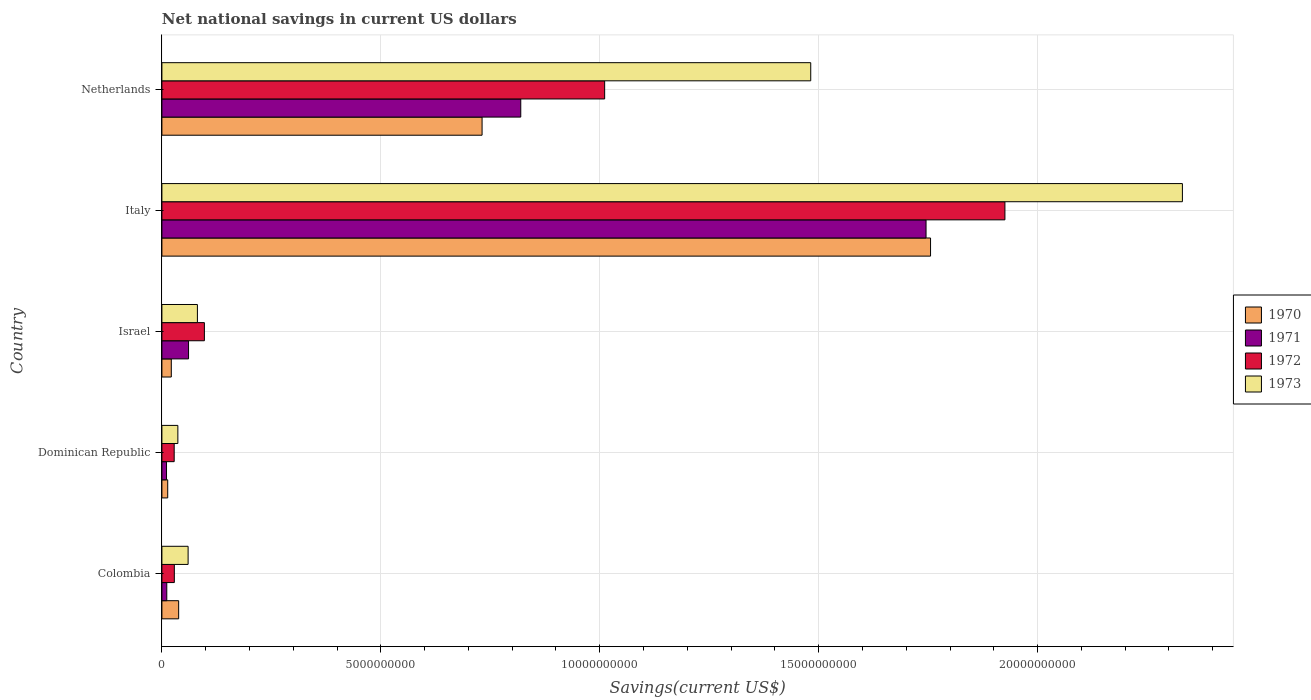Are the number of bars per tick equal to the number of legend labels?
Ensure brevity in your answer.  Yes. How many bars are there on the 2nd tick from the top?
Keep it short and to the point. 4. What is the label of the 3rd group of bars from the top?
Offer a terse response. Israel. What is the net national savings in 1972 in Colombia?
Your response must be concise. 2.84e+08. Across all countries, what is the maximum net national savings in 1973?
Ensure brevity in your answer.  2.33e+1. Across all countries, what is the minimum net national savings in 1970?
Ensure brevity in your answer.  1.33e+08. In which country was the net national savings in 1971 maximum?
Ensure brevity in your answer.  Italy. In which country was the net national savings in 1971 minimum?
Make the answer very short. Dominican Republic. What is the total net national savings in 1972 in the graph?
Your response must be concise. 3.09e+1. What is the difference between the net national savings in 1970 in Colombia and that in Israel?
Your answer should be compact. 1.68e+08. What is the difference between the net national savings in 1972 in Colombia and the net national savings in 1973 in Netherlands?
Offer a very short reply. -1.45e+1. What is the average net national savings in 1972 per country?
Provide a succinct answer. 6.18e+09. What is the difference between the net national savings in 1972 and net national savings in 1971 in Dominican Republic?
Provide a short and direct response. 1.75e+08. In how many countries, is the net national savings in 1973 greater than 11000000000 US$?
Make the answer very short. 2. What is the ratio of the net national savings in 1971 in Dominican Republic to that in Italy?
Keep it short and to the point. 0.01. What is the difference between the highest and the second highest net national savings in 1973?
Make the answer very short. 8.49e+09. What is the difference between the highest and the lowest net national savings in 1973?
Ensure brevity in your answer.  2.29e+1. Is the sum of the net national savings in 1972 in Colombia and Italy greater than the maximum net national savings in 1973 across all countries?
Make the answer very short. No. Is it the case that in every country, the sum of the net national savings in 1971 and net national savings in 1970 is greater than the sum of net national savings in 1972 and net national savings in 1973?
Your answer should be very brief. No. How many bars are there?
Offer a very short reply. 20. How many countries are there in the graph?
Ensure brevity in your answer.  5. What is the difference between two consecutive major ticks on the X-axis?
Give a very brief answer. 5.00e+09. Does the graph contain grids?
Your response must be concise. Yes. How many legend labels are there?
Provide a short and direct response. 4. What is the title of the graph?
Give a very brief answer. Net national savings in current US dollars. What is the label or title of the X-axis?
Provide a short and direct response. Savings(current US$). What is the label or title of the Y-axis?
Offer a terse response. Country. What is the Savings(current US$) of 1970 in Colombia?
Your answer should be very brief. 3.83e+08. What is the Savings(current US$) of 1971 in Colombia?
Provide a short and direct response. 1.11e+08. What is the Savings(current US$) in 1972 in Colombia?
Offer a very short reply. 2.84e+08. What is the Savings(current US$) of 1973 in Colombia?
Your answer should be very brief. 5.98e+08. What is the Savings(current US$) of 1970 in Dominican Republic?
Ensure brevity in your answer.  1.33e+08. What is the Savings(current US$) in 1971 in Dominican Republic?
Provide a short and direct response. 1.05e+08. What is the Savings(current US$) of 1972 in Dominican Republic?
Make the answer very short. 2.80e+08. What is the Savings(current US$) of 1973 in Dominican Republic?
Ensure brevity in your answer.  3.65e+08. What is the Savings(current US$) in 1970 in Israel?
Your answer should be very brief. 2.15e+08. What is the Savings(current US$) of 1971 in Israel?
Give a very brief answer. 6.09e+08. What is the Savings(current US$) of 1972 in Israel?
Give a very brief answer. 9.71e+08. What is the Savings(current US$) in 1973 in Israel?
Offer a terse response. 8.11e+08. What is the Savings(current US$) in 1970 in Italy?
Make the answer very short. 1.76e+1. What is the Savings(current US$) in 1971 in Italy?
Make the answer very short. 1.75e+1. What is the Savings(current US$) of 1972 in Italy?
Give a very brief answer. 1.93e+1. What is the Savings(current US$) in 1973 in Italy?
Keep it short and to the point. 2.33e+1. What is the Savings(current US$) of 1970 in Netherlands?
Give a very brief answer. 7.31e+09. What is the Savings(current US$) of 1971 in Netherlands?
Keep it short and to the point. 8.20e+09. What is the Savings(current US$) in 1972 in Netherlands?
Ensure brevity in your answer.  1.01e+1. What is the Savings(current US$) in 1973 in Netherlands?
Ensure brevity in your answer.  1.48e+1. Across all countries, what is the maximum Savings(current US$) of 1970?
Keep it short and to the point. 1.76e+1. Across all countries, what is the maximum Savings(current US$) in 1971?
Your answer should be very brief. 1.75e+1. Across all countries, what is the maximum Savings(current US$) of 1972?
Ensure brevity in your answer.  1.93e+1. Across all countries, what is the maximum Savings(current US$) of 1973?
Give a very brief answer. 2.33e+1. Across all countries, what is the minimum Savings(current US$) in 1970?
Your response must be concise. 1.33e+08. Across all countries, what is the minimum Savings(current US$) of 1971?
Offer a very short reply. 1.05e+08. Across all countries, what is the minimum Savings(current US$) of 1972?
Provide a succinct answer. 2.80e+08. Across all countries, what is the minimum Savings(current US$) in 1973?
Ensure brevity in your answer.  3.65e+08. What is the total Savings(current US$) in 1970 in the graph?
Your response must be concise. 2.56e+1. What is the total Savings(current US$) of 1971 in the graph?
Offer a terse response. 2.65e+1. What is the total Savings(current US$) in 1972 in the graph?
Your answer should be compact. 3.09e+1. What is the total Savings(current US$) of 1973 in the graph?
Offer a very short reply. 3.99e+1. What is the difference between the Savings(current US$) of 1970 in Colombia and that in Dominican Republic?
Provide a succinct answer. 2.50e+08. What is the difference between the Savings(current US$) in 1971 in Colombia and that in Dominican Republic?
Your response must be concise. 6.03e+06. What is the difference between the Savings(current US$) of 1972 in Colombia and that in Dominican Republic?
Provide a short and direct response. 3.48e+06. What is the difference between the Savings(current US$) in 1973 in Colombia and that in Dominican Republic?
Give a very brief answer. 2.34e+08. What is the difference between the Savings(current US$) of 1970 in Colombia and that in Israel?
Your answer should be compact. 1.68e+08. What is the difference between the Savings(current US$) of 1971 in Colombia and that in Israel?
Provide a short and direct response. -4.97e+08. What is the difference between the Savings(current US$) in 1972 in Colombia and that in Israel?
Make the answer very short. -6.87e+08. What is the difference between the Savings(current US$) of 1973 in Colombia and that in Israel?
Offer a terse response. -2.12e+08. What is the difference between the Savings(current US$) of 1970 in Colombia and that in Italy?
Ensure brevity in your answer.  -1.72e+1. What is the difference between the Savings(current US$) in 1971 in Colombia and that in Italy?
Keep it short and to the point. -1.73e+1. What is the difference between the Savings(current US$) in 1972 in Colombia and that in Italy?
Ensure brevity in your answer.  -1.90e+1. What is the difference between the Savings(current US$) of 1973 in Colombia and that in Italy?
Offer a terse response. -2.27e+1. What is the difference between the Savings(current US$) of 1970 in Colombia and that in Netherlands?
Your response must be concise. -6.93e+09. What is the difference between the Savings(current US$) of 1971 in Colombia and that in Netherlands?
Offer a terse response. -8.08e+09. What is the difference between the Savings(current US$) of 1972 in Colombia and that in Netherlands?
Keep it short and to the point. -9.83e+09. What is the difference between the Savings(current US$) of 1973 in Colombia and that in Netherlands?
Keep it short and to the point. -1.42e+1. What is the difference between the Savings(current US$) in 1970 in Dominican Republic and that in Israel?
Provide a succinct answer. -8.19e+07. What is the difference between the Savings(current US$) of 1971 in Dominican Republic and that in Israel?
Give a very brief answer. -5.03e+08. What is the difference between the Savings(current US$) in 1972 in Dominican Republic and that in Israel?
Your response must be concise. -6.90e+08. What is the difference between the Savings(current US$) in 1973 in Dominican Republic and that in Israel?
Make the answer very short. -4.46e+08. What is the difference between the Savings(current US$) of 1970 in Dominican Republic and that in Italy?
Your answer should be compact. -1.74e+1. What is the difference between the Savings(current US$) of 1971 in Dominican Republic and that in Italy?
Provide a succinct answer. -1.73e+1. What is the difference between the Savings(current US$) of 1972 in Dominican Republic and that in Italy?
Ensure brevity in your answer.  -1.90e+1. What is the difference between the Savings(current US$) of 1973 in Dominican Republic and that in Italy?
Make the answer very short. -2.29e+1. What is the difference between the Savings(current US$) of 1970 in Dominican Republic and that in Netherlands?
Make the answer very short. -7.18e+09. What is the difference between the Savings(current US$) of 1971 in Dominican Republic and that in Netherlands?
Offer a terse response. -8.09e+09. What is the difference between the Savings(current US$) of 1972 in Dominican Republic and that in Netherlands?
Keep it short and to the point. -9.83e+09. What is the difference between the Savings(current US$) in 1973 in Dominican Republic and that in Netherlands?
Keep it short and to the point. -1.45e+1. What is the difference between the Savings(current US$) of 1970 in Israel and that in Italy?
Your answer should be compact. -1.73e+1. What is the difference between the Savings(current US$) of 1971 in Israel and that in Italy?
Your response must be concise. -1.68e+1. What is the difference between the Savings(current US$) of 1972 in Israel and that in Italy?
Offer a terse response. -1.83e+1. What is the difference between the Savings(current US$) of 1973 in Israel and that in Italy?
Provide a short and direct response. -2.25e+1. What is the difference between the Savings(current US$) in 1970 in Israel and that in Netherlands?
Your answer should be very brief. -7.10e+09. What is the difference between the Savings(current US$) of 1971 in Israel and that in Netherlands?
Give a very brief answer. -7.59e+09. What is the difference between the Savings(current US$) of 1972 in Israel and that in Netherlands?
Give a very brief answer. -9.14e+09. What is the difference between the Savings(current US$) of 1973 in Israel and that in Netherlands?
Make the answer very short. -1.40e+1. What is the difference between the Savings(current US$) of 1970 in Italy and that in Netherlands?
Offer a very short reply. 1.02e+1. What is the difference between the Savings(current US$) in 1971 in Italy and that in Netherlands?
Provide a short and direct response. 9.26e+09. What is the difference between the Savings(current US$) in 1972 in Italy and that in Netherlands?
Ensure brevity in your answer.  9.14e+09. What is the difference between the Savings(current US$) of 1973 in Italy and that in Netherlands?
Give a very brief answer. 8.49e+09. What is the difference between the Savings(current US$) in 1970 in Colombia and the Savings(current US$) in 1971 in Dominican Republic?
Your response must be concise. 2.77e+08. What is the difference between the Savings(current US$) of 1970 in Colombia and the Savings(current US$) of 1972 in Dominican Republic?
Ensure brevity in your answer.  1.02e+08. What is the difference between the Savings(current US$) of 1970 in Colombia and the Savings(current US$) of 1973 in Dominican Republic?
Give a very brief answer. 1.82e+07. What is the difference between the Savings(current US$) of 1971 in Colombia and the Savings(current US$) of 1972 in Dominican Republic?
Give a very brief answer. -1.69e+08. What is the difference between the Savings(current US$) of 1971 in Colombia and the Savings(current US$) of 1973 in Dominican Republic?
Your response must be concise. -2.53e+08. What is the difference between the Savings(current US$) in 1972 in Colombia and the Savings(current US$) in 1973 in Dominican Republic?
Ensure brevity in your answer.  -8.05e+07. What is the difference between the Savings(current US$) in 1970 in Colombia and the Savings(current US$) in 1971 in Israel?
Ensure brevity in your answer.  -2.26e+08. What is the difference between the Savings(current US$) in 1970 in Colombia and the Savings(current US$) in 1972 in Israel?
Keep it short and to the point. -5.88e+08. What is the difference between the Savings(current US$) of 1970 in Colombia and the Savings(current US$) of 1973 in Israel?
Your answer should be compact. -4.28e+08. What is the difference between the Savings(current US$) of 1971 in Colombia and the Savings(current US$) of 1972 in Israel?
Your answer should be very brief. -8.59e+08. What is the difference between the Savings(current US$) of 1971 in Colombia and the Savings(current US$) of 1973 in Israel?
Offer a terse response. -6.99e+08. What is the difference between the Savings(current US$) of 1972 in Colombia and the Savings(current US$) of 1973 in Israel?
Your answer should be very brief. -5.27e+08. What is the difference between the Savings(current US$) of 1970 in Colombia and the Savings(current US$) of 1971 in Italy?
Your response must be concise. -1.71e+1. What is the difference between the Savings(current US$) of 1970 in Colombia and the Savings(current US$) of 1972 in Italy?
Provide a succinct answer. -1.89e+1. What is the difference between the Savings(current US$) of 1970 in Colombia and the Savings(current US$) of 1973 in Italy?
Offer a very short reply. -2.29e+1. What is the difference between the Savings(current US$) of 1971 in Colombia and the Savings(current US$) of 1972 in Italy?
Ensure brevity in your answer.  -1.91e+1. What is the difference between the Savings(current US$) in 1971 in Colombia and the Savings(current US$) in 1973 in Italy?
Provide a succinct answer. -2.32e+1. What is the difference between the Savings(current US$) in 1972 in Colombia and the Savings(current US$) in 1973 in Italy?
Make the answer very short. -2.30e+1. What is the difference between the Savings(current US$) of 1970 in Colombia and the Savings(current US$) of 1971 in Netherlands?
Keep it short and to the point. -7.81e+09. What is the difference between the Savings(current US$) in 1970 in Colombia and the Savings(current US$) in 1972 in Netherlands?
Your response must be concise. -9.73e+09. What is the difference between the Savings(current US$) of 1970 in Colombia and the Savings(current US$) of 1973 in Netherlands?
Your answer should be compact. -1.44e+1. What is the difference between the Savings(current US$) of 1971 in Colombia and the Savings(current US$) of 1972 in Netherlands?
Offer a very short reply. -1.00e+1. What is the difference between the Savings(current US$) of 1971 in Colombia and the Savings(current US$) of 1973 in Netherlands?
Your answer should be compact. -1.47e+1. What is the difference between the Savings(current US$) in 1972 in Colombia and the Savings(current US$) in 1973 in Netherlands?
Your answer should be very brief. -1.45e+1. What is the difference between the Savings(current US$) of 1970 in Dominican Republic and the Savings(current US$) of 1971 in Israel?
Offer a terse response. -4.76e+08. What is the difference between the Savings(current US$) of 1970 in Dominican Republic and the Savings(current US$) of 1972 in Israel?
Your answer should be very brief. -8.38e+08. What is the difference between the Savings(current US$) in 1970 in Dominican Republic and the Savings(current US$) in 1973 in Israel?
Ensure brevity in your answer.  -6.78e+08. What is the difference between the Savings(current US$) of 1971 in Dominican Republic and the Savings(current US$) of 1972 in Israel?
Give a very brief answer. -8.65e+08. What is the difference between the Savings(current US$) in 1971 in Dominican Republic and the Savings(current US$) in 1973 in Israel?
Offer a very short reply. -7.05e+08. What is the difference between the Savings(current US$) in 1972 in Dominican Republic and the Savings(current US$) in 1973 in Israel?
Provide a succinct answer. -5.30e+08. What is the difference between the Savings(current US$) of 1970 in Dominican Republic and the Savings(current US$) of 1971 in Italy?
Offer a very short reply. -1.73e+1. What is the difference between the Savings(current US$) in 1970 in Dominican Republic and the Savings(current US$) in 1972 in Italy?
Your answer should be compact. -1.91e+1. What is the difference between the Savings(current US$) in 1970 in Dominican Republic and the Savings(current US$) in 1973 in Italy?
Provide a short and direct response. -2.32e+1. What is the difference between the Savings(current US$) of 1971 in Dominican Republic and the Savings(current US$) of 1972 in Italy?
Give a very brief answer. -1.91e+1. What is the difference between the Savings(current US$) of 1971 in Dominican Republic and the Savings(current US$) of 1973 in Italy?
Make the answer very short. -2.32e+1. What is the difference between the Savings(current US$) in 1972 in Dominican Republic and the Savings(current US$) in 1973 in Italy?
Keep it short and to the point. -2.30e+1. What is the difference between the Savings(current US$) in 1970 in Dominican Republic and the Savings(current US$) in 1971 in Netherlands?
Your answer should be very brief. -8.06e+09. What is the difference between the Savings(current US$) in 1970 in Dominican Republic and the Savings(current US$) in 1972 in Netherlands?
Give a very brief answer. -9.98e+09. What is the difference between the Savings(current US$) in 1970 in Dominican Republic and the Savings(current US$) in 1973 in Netherlands?
Your answer should be compact. -1.47e+1. What is the difference between the Savings(current US$) of 1971 in Dominican Republic and the Savings(current US$) of 1972 in Netherlands?
Make the answer very short. -1.00e+1. What is the difference between the Savings(current US$) of 1971 in Dominican Republic and the Savings(current US$) of 1973 in Netherlands?
Offer a terse response. -1.47e+1. What is the difference between the Savings(current US$) in 1972 in Dominican Republic and the Savings(current US$) in 1973 in Netherlands?
Your answer should be very brief. -1.45e+1. What is the difference between the Savings(current US$) of 1970 in Israel and the Savings(current US$) of 1971 in Italy?
Make the answer very short. -1.72e+1. What is the difference between the Savings(current US$) of 1970 in Israel and the Savings(current US$) of 1972 in Italy?
Give a very brief answer. -1.90e+1. What is the difference between the Savings(current US$) of 1970 in Israel and the Savings(current US$) of 1973 in Italy?
Your answer should be very brief. -2.31e+1. What is the difference between the Savings(current US$) in 1971 in Israel and the Savings(current US$) in 1972 in Italy?
Your response must be concise. -1.86e+1. What is the difference between the Savings(current US$) in 1971 in Israel and the Savings(current US$) in 1973 in Italy?
Ensure brevity in your answer.  -2.27e+1. What is the difference between the Savings(current US$) of 1972 in Israel and the Savings(current US$) of 1973 in Italy?
Offer a very short reply. -2.23e+1. What is the difference between the Savings(current US$) in 1970 in Israel and the Savings(current US$) in 1971 in Netherlands?
Offer a terse response. -7.98e+09. What is the difference between the Savings(current US$) in 1970 in Israel and the Savings(current US$) in 1972 in Netherlands?
Offer a very short reply. -9.90e+09. What is the difference between the Savings(current US$) of 1970 in Israel and the Savings(current US$) of 1973 in Netherlands?
Your answer should be very brief. -1.46e+1. What is the difference between the Savings(current US$) of 1971 in Israel and the Savings(current US$) of 1972 in Netherlands?
Your answer should be very brief. -9.50e+09. What is the difference between the Savings(current US$) in 1971 in Israel and the Savings(current US$) in 1973 in Netherlands?
Give a very brief answer. -1.42e+1. What is the difference between the Savings(current US$) in 1972 in Israel and the Savings(current US$) in 1973 in Netherlands?
Provide a short and direct response. -1.38e+1. What is the difference between the Savings(current US$) in 1970 in Italy and the Savings(current US$) in 1971 in Netherlands?
Provide a succinct answer. 9.36e+09. What is the difference between the Savings(current US$) in 1970 in Italy and the Savings(current US$) in 1972 in Netherlands?
Your answer should be very brief. 7.44e+09. What is the difference between the Savings(current US$) in 1970 in Italy and the Savings(current US$) in 1973 in Netherlands?
Your response must be concise. 2.74e+09. What is the difference between the Savings(current US$) in 1971 in Italy and the Savings(current US$) in 1972 in Netherlands?
Make the answer very short. 7.34e+09. What is the difference between the Savings(current US$) in 1971 in Italy and the Savings(current US$) in 1973 in Netherlands?
Give a very brief answer. 2.63e+09. What is the difference between the Savings(current US$) of 1972 in Italy and the Savings(current US$) of 1973 in Netherlands?
Provide a short and direct response. 4.44e+09. What is the average Savings(current US$) in 1970 per country?
Provide a succinct answer. 5.12e+09. What is the average Savings(current US$) in 1971 per country?
Your answer should be compact. 5.29e+09. What is the average Savings(current US$) in 1972 per country?
Keep it short and to the point. 6.18e+09. What is the average Savings(current US$) of 1973 per country?
Make the answer very short. 7.98e+09. What is the difference between the Savings(current US$) in 1970 and Savings(current US$) in 1971 in Colombia?
Keep it short and to the point. 2.71e+08. What is the difference between the Savings(current US$) of 1970 and Savings(current US$) of 1972 in Colombia?
Your answer should be compact. 9.87e+07. What is the difference between the Savings(current US$) of 1970 and Savings(current US$) of 1973 in Colombia?
Provide a succinct answer. -2.16e+08. What is the difference between the Savings(current US$) in 1971 and Savings(current US$) in 1972 in Colombia?
Offer a very short reply. -1.73e+08. What is the difference between the Savings(current US$) in 1971 and Savings(current US$) in 1973 in Colombia?
Make the answer very short. -4.87e+08. What is the difference between the Savings(current US$) of 1972 and Savings(current US$) of 1973 in Colombia?
Offer a terse response. -3.14e+08. What is the difference between the Savings(current US$) in 1970 and Savings(current US$) in 1971 in Dominican Republic?
Make the answer very short. 2.74e+07. What is the difference between the Savings(current US$) of 1970 and Savings(current US$) of 1972 in Dominican Republic?
Ensure brevity in your answer.  -1.48e+08. What is the difference between the Savings(current US$) in 1970 and Savings(current US$) in 1973 in Dominican Republic?
Your response must be concise. -2.32e+08. What is the difference between the Savings(current US$) of 1971 and Savings(current US$) of 1972 in Dominican Republic?
Your response must be concise. -1.75e+08. What is the difference between the Savings(current US$) in 1971 and Savings(current US$) in 1973 in Dominican Republic?
Your answer should be compact. -2.59e+08. What is the difference between the Savings(current US$) in 1972 and Savings(current US$) in 1973 in Dominican Republic?
Offer a terse response. -8.40e+07. What is the difference between the Savings(current US$) in 1970 and Savings(current US$) in 1971 in Israel?
Provide a succinct answer. -3.94e+08. What is the difference between the Savings(current US$) in 1970 and Savings(current US$) in 1972 in Israel?
Keep it short and to the point. -7.56e+08. What is the difference between the Savings(current US$) in 1970 and Savings(current US$) in 1973 in Israel?
Your answer should be very brief. -5.96e+08. What is the difference between the Savings(current US$) in 1971 and Savings(current US$) in 1972 in Israel?
Provide a succinct answer. -3.62e+08. What is the difference between the Savings(current US$) in 1971 and Savings(current US$) in 1973 in Israel?
Your answer should be compact. -2.02e+08. What is the difference between the Savings(current US$) in 1972 and Savings(current US$) in 1973 in Israel?
Keep it short and to the point. 1.60e+08. What is the difference between the Savings(current US$) in 1970 and Savings(current US$) in 1971 in Italy?
Your answer should be very brief. 1.03e+08. What is the difference between the Savings(current US$) in 1970 and Savings(current US$) in 1972 in Italy?
Your answer should be very brief. -1.70e+09. What is the difference between the Savings(current US$) of 1970 and Savings(current US$) of 1973 in Italy?
Offer a terse response. -5.75e+09. What is the difference between the Savings(current US$) in 1971 and Savings(current US$) in 1972 in Italy?
Ensure brevity in your answer.  -1.80e+09. What is the difference between the Savings(current US$) of 1971 and Savings(current US$) of 1973 in Italy?
Your answer should be compact. -5.86e+09. What is the difference between the Savings(current US$) in 1972 and Savings(current US$) in 1973 in Italy?
Offer a terse response. -4.05e+09. What is the difference between the Savings(current US$) in 1970 and Savings(current US$) in 1971 in Netherlands?
Offer a terse response. -8.83e+08. What is the difference between the Savings(current US$) in 1970 and Savings(current US$) in 1972 in Netherlands?
Offer a terse response. -2.80e+09. What is the difference between the Savings(current US$) of 1970 and Savings(current US$) of 1973 in Netherlands?
Offer a terse response. -7.51e+09. What is the difference between the Savings(current US$) in 1971 and Savings(current US$) in 1972 in Netherlands?
Your answer should be very brief. -1.92e+09. What is the difference between the Savings(current US$) of 1971 and Savings(current US$) of 1973 in Netherlands?
Ensure brevity in your answer.  -6.62e+09. What is the difference between the Savings(current US$) in 1972 and Savings(current US$) in 1973 in Netherlands?
Ensure brevity in your answer.  -4.71e+09. What is the ratio of the Savings(current US$) of 1970 in Colombia to that in Dominican Republic?
Your answer should be compact. 2.88. What is the ratio of the Savings(current US$) of 1971 in Colombia to that in Dominican Republic?
Your response must be concise. 1.06. What is the ratio of the Savings(current US$) in 1972 in Colombia to that in Dominican Republic?
Provide a succinct answer. 1.01. What is the ratio of the Savings(current US$) in 1973 in Colombia to that in Dominican Republic?
Ensure brevity in your answer.  1.64. What is the ratio of the Savings(current US$) of 1970 in Colombia to that in Israel?
Your answer should be compact. 1.78. What is the ratio of the Savings(current US$) in 1971 in Colombia to that in Israel?
Ensure brevity in your answer.  0.18. What is the ratio of the Savings(current US$) in 1972 in Colombia to that in Israel?
Offer a terse response. 0.29. What is the ratio of the Savings(current US$) of 1973 in Colombia to that in Israel?
Keep it short and to the point. 0.74. What is the ratio of the Savings(current US$) of 1970 in Colombia to that in Italy?
Your answer should be very brief. 0.02. What is the ratio of the Savings(current US$) of 1971 in Colombia to that in Italy?
Your response must be concise. 0.01. What is the ratio of the Savings(current US$) of 1972 in Colombia to that in Italy?
Provide a short and direct response. 0.01. What is the ratio of the Savings(current US$) of 1973 in Colombia to that in Italy?
Give a very brief answer. 0.03. What is the ratio of the Savings(current US$) in 1970 in Colombia to that in Netherlands?
Your response must be concise. 0.05. What is the ratio of the Savings(current US$) of 1971 in Colombia to that in Netherlands?
Give a very brief answer. 0.01. What is the ratio of the Savings(current US$) in 1972 in Colombia to that in Netherlands?
Provide a succinct answer. 0.03. What is the ratio of the Savings(current US$) in 1973 in Colombia to that in Netherlands?
Provide a succinct answer. 0.04. What is the ratio of the Savings(current US$) in 1970 in Dominican Republic to that in Israel?
Give a very brief answer. 0.62. What is the ratio of the Savings(current US$) in 1971 in Dominican Republic to that in Israel?
Make the answer very short. 0.17. What is the ratio of the Savings(current US$) of 1972 in Dominican Republic to that in Israel?
Offer a terse response. 0.29. What is the ratio of the Savings(current US$) in 1973 in Dominican Republic to that in Israel?
Make the answer very short. 0.45. What is the ratio of the Savings(current US$) of 1970 in Dominican Republic to that in Italy?
Provide a succinct answer. 0.01. What is the ratio of the Savings(current US$) in 1971 in Dominican Republic to that in Italy?
Give a very brief answer. 0.01. What is the ratio of the Savings(current US$) in 1972 in Dominican Republic to that in Italy?
Your response must be concise. 0.01. What is the ratio of the Savings(current US$) of 1973 in Dominican Republic to that in Italy?
Your answer should be compact. 0.02. What is the ratio of the Savings(current US$) in 1970 in Dominican Republic to that in Netherlands?
Offer a very short reply. 0.02. What is the ratio of the Savings(current US$) in 1971 in Dominican Republic to that in Netherlands?
Your answer should be very brief. 0.01. What is the ratio of the Savings(current US$) of 1972 in Dominican Republic to that in Netherlands?
Keep it short and to the point. 0.03. What is the ratio of the Savings(current US$) of 1973 in Dominican Republic to that in Netherlands?
Your answer should be very brief. 0.02. What is the ratio of the Savings(current US$) of 1970 in Israel to that in Italy?
Give a very brief answer. 0.01. What is the ratio of the Savings(current US$) of 1971 in Israel to that in Italy?
Make the answer very short. 0.03. What is the ratio of the Savings(current US$) of 1972 in Israel to that in Italy?
Ensure brevity in your answer.  0.05. What is the ratio of the Savings(current US$) of 1973 in Israel to that in Italy?
Offer a very short reply. 0.03. What is the ratio of the Savings(current US$) of 1970 in Israel to that in Netherlands?
Keep it short and to the point. 0.03. What is the ratio of the Savings(current US$) of 1971 in Israel to that in Netherlands?
Your answer should be compact. 0.07. What is the ratio of the Savings(current US$) of 1972 in Israel to that in Netherlands?
Your response must be concise. 0.1. What is the ratio of the Savings(current US$) of 1973 in Israel to that in Netherlands?
Ensure brevity in your answer.  0.05. What is the ratio of the Savings(current US$) in 1970 in Italy to that in Netherlands?
Provide a succinct answer. 2.4. What is the ratio of the Savings(current US$) in 1971 in Italy to that in Netherlands?
Offer a terse response. 2.13. What is the ratio of the Savings(current US$) of 1972 in Italy to that in Netherlands?
Offer a terse response. 1.9. What is the ratio of the Savings(current US$) of 1973 in Italy to that in Netherlands?
Your response must be concise. 1.57. What is the difference between the highest and the second highest Savings(current US$) of 1970?
Keep it short and to the point. 1.02e+1. What is the difference between the highest and the second highest Savings(current US$) of 1971?
Offer a terse response. 9.26e+09. What is the difference between the highest and the second highest Savings(current US$) in 1972?
Provide a short and direct response. 9.14e+09. What is the difference between the highest and the second highest Savings(current US$) in 1973?
Provide a short and direct response. 8.49e+09. What is the difference between the highest and the lowest Savings(current US$) of 1970?
Your response must be concise. 1.74e+1. What is the difference between the highest and the lowest Savings(current US$) of 1971?
Provide a short and direct response. 1.73e+1. What is the difference between the highest and the lowest Savings(current US$) of 1972?
Provide a short and direct response. 1.90e+1. What is the difference between the highest and the lowest Savings(current US$) of 1973?
Your response must be concise. 2.29e+1. 